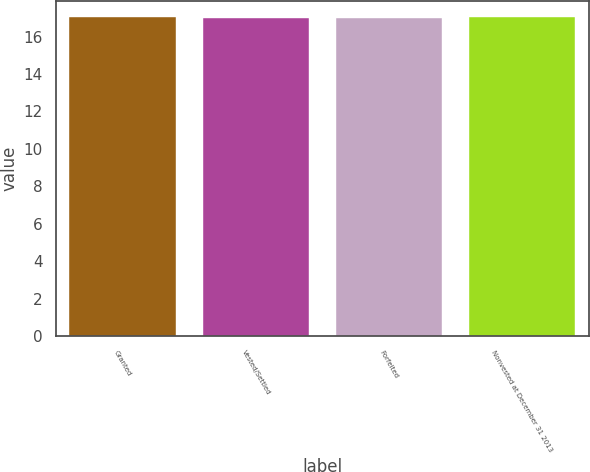<chart> <loc_0><loc_0><loc_500><loc_500><bar_chart><fcel>Granted<fcel>Vested/Settled<fcel>Forfeited<fcel>Nonvested at December 31 2013<nl><fcel>17.03<fcel>17<fcel>17.01<fcel>17.04<nl></chart> 